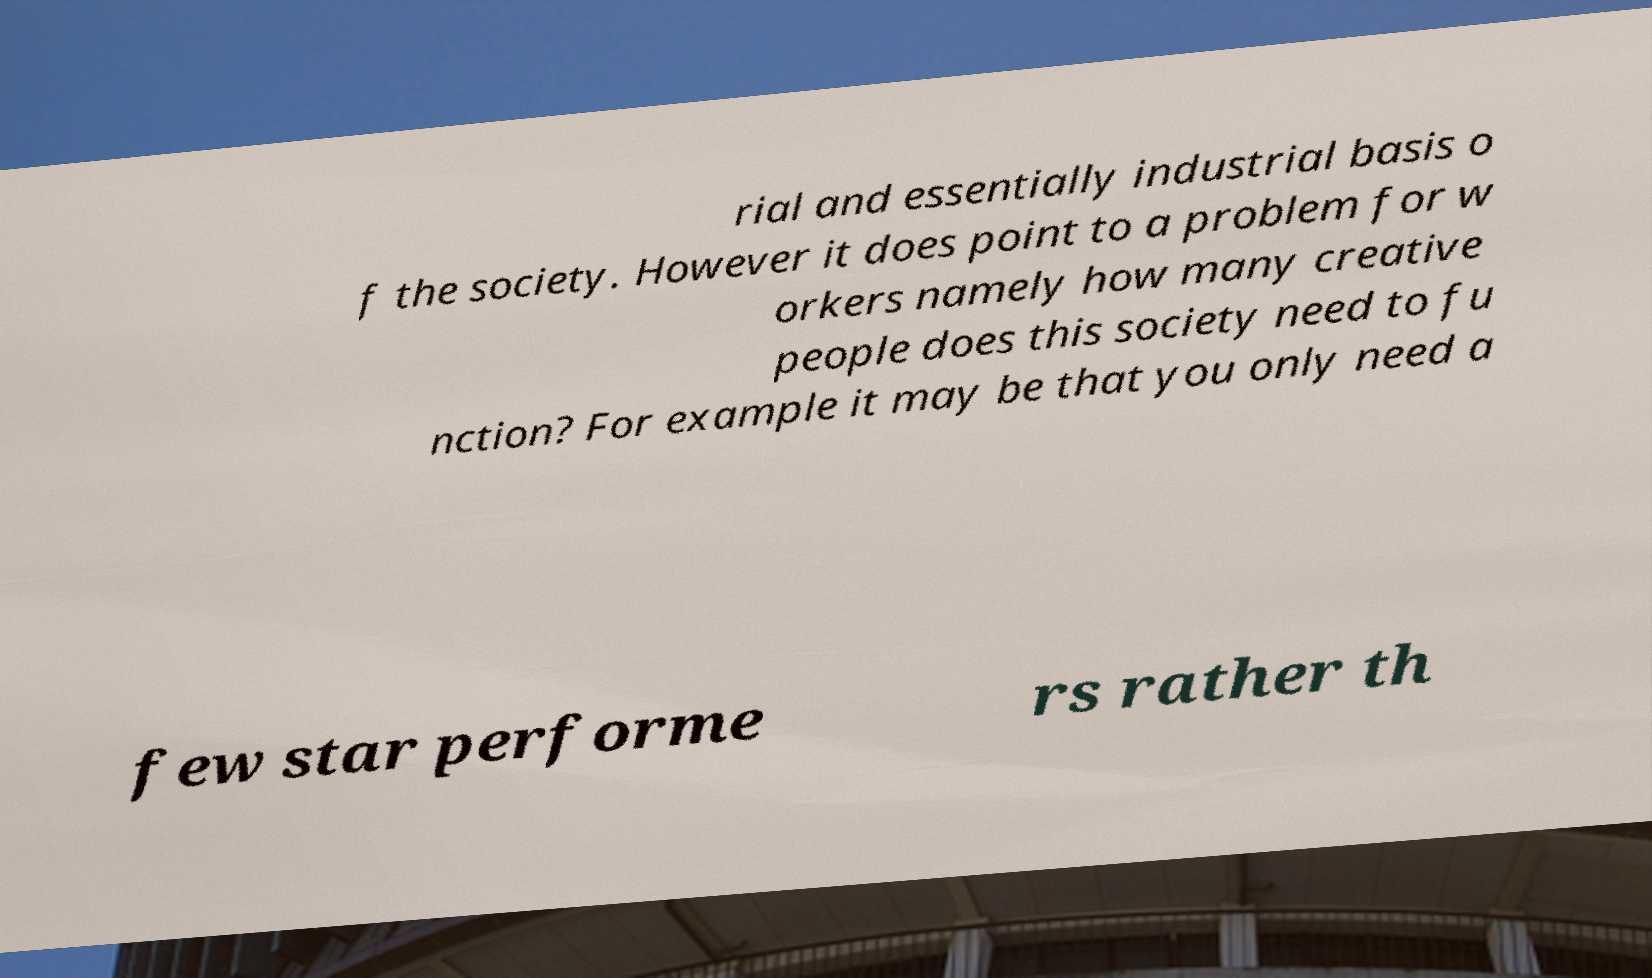Please identify and transcribe the text found in this image. rial and essentially industrial basis o f the society. However it does point to a problem for w orkers namely how many creative people does this society need to fu nction? For example it may be that you only need a few star performe rs rather th 